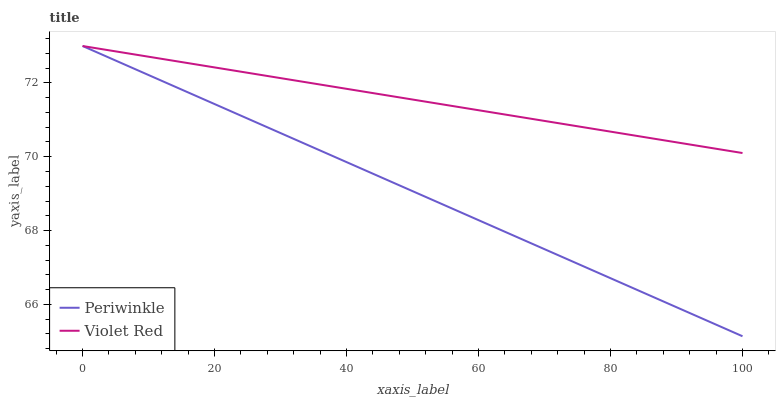Does Periwinkle have the minimum area under the curve?
Answer yes or no. Yes. Does Violet Red have the maximum area under the curve?
Answer yes or no. Yes. Does Periwinkle have the maximum area under the curve?
Answer yes or no. No. Is Violet Red the smoothest?
Answer yes or no. Yes. Is Periwinkle the roughest?
Answer yes or no. Yes. Is Periwinkle the smoothest?
Answer yes or no. No. Does Periwinkle have the highest value?
Answer yes or no. Yes. 